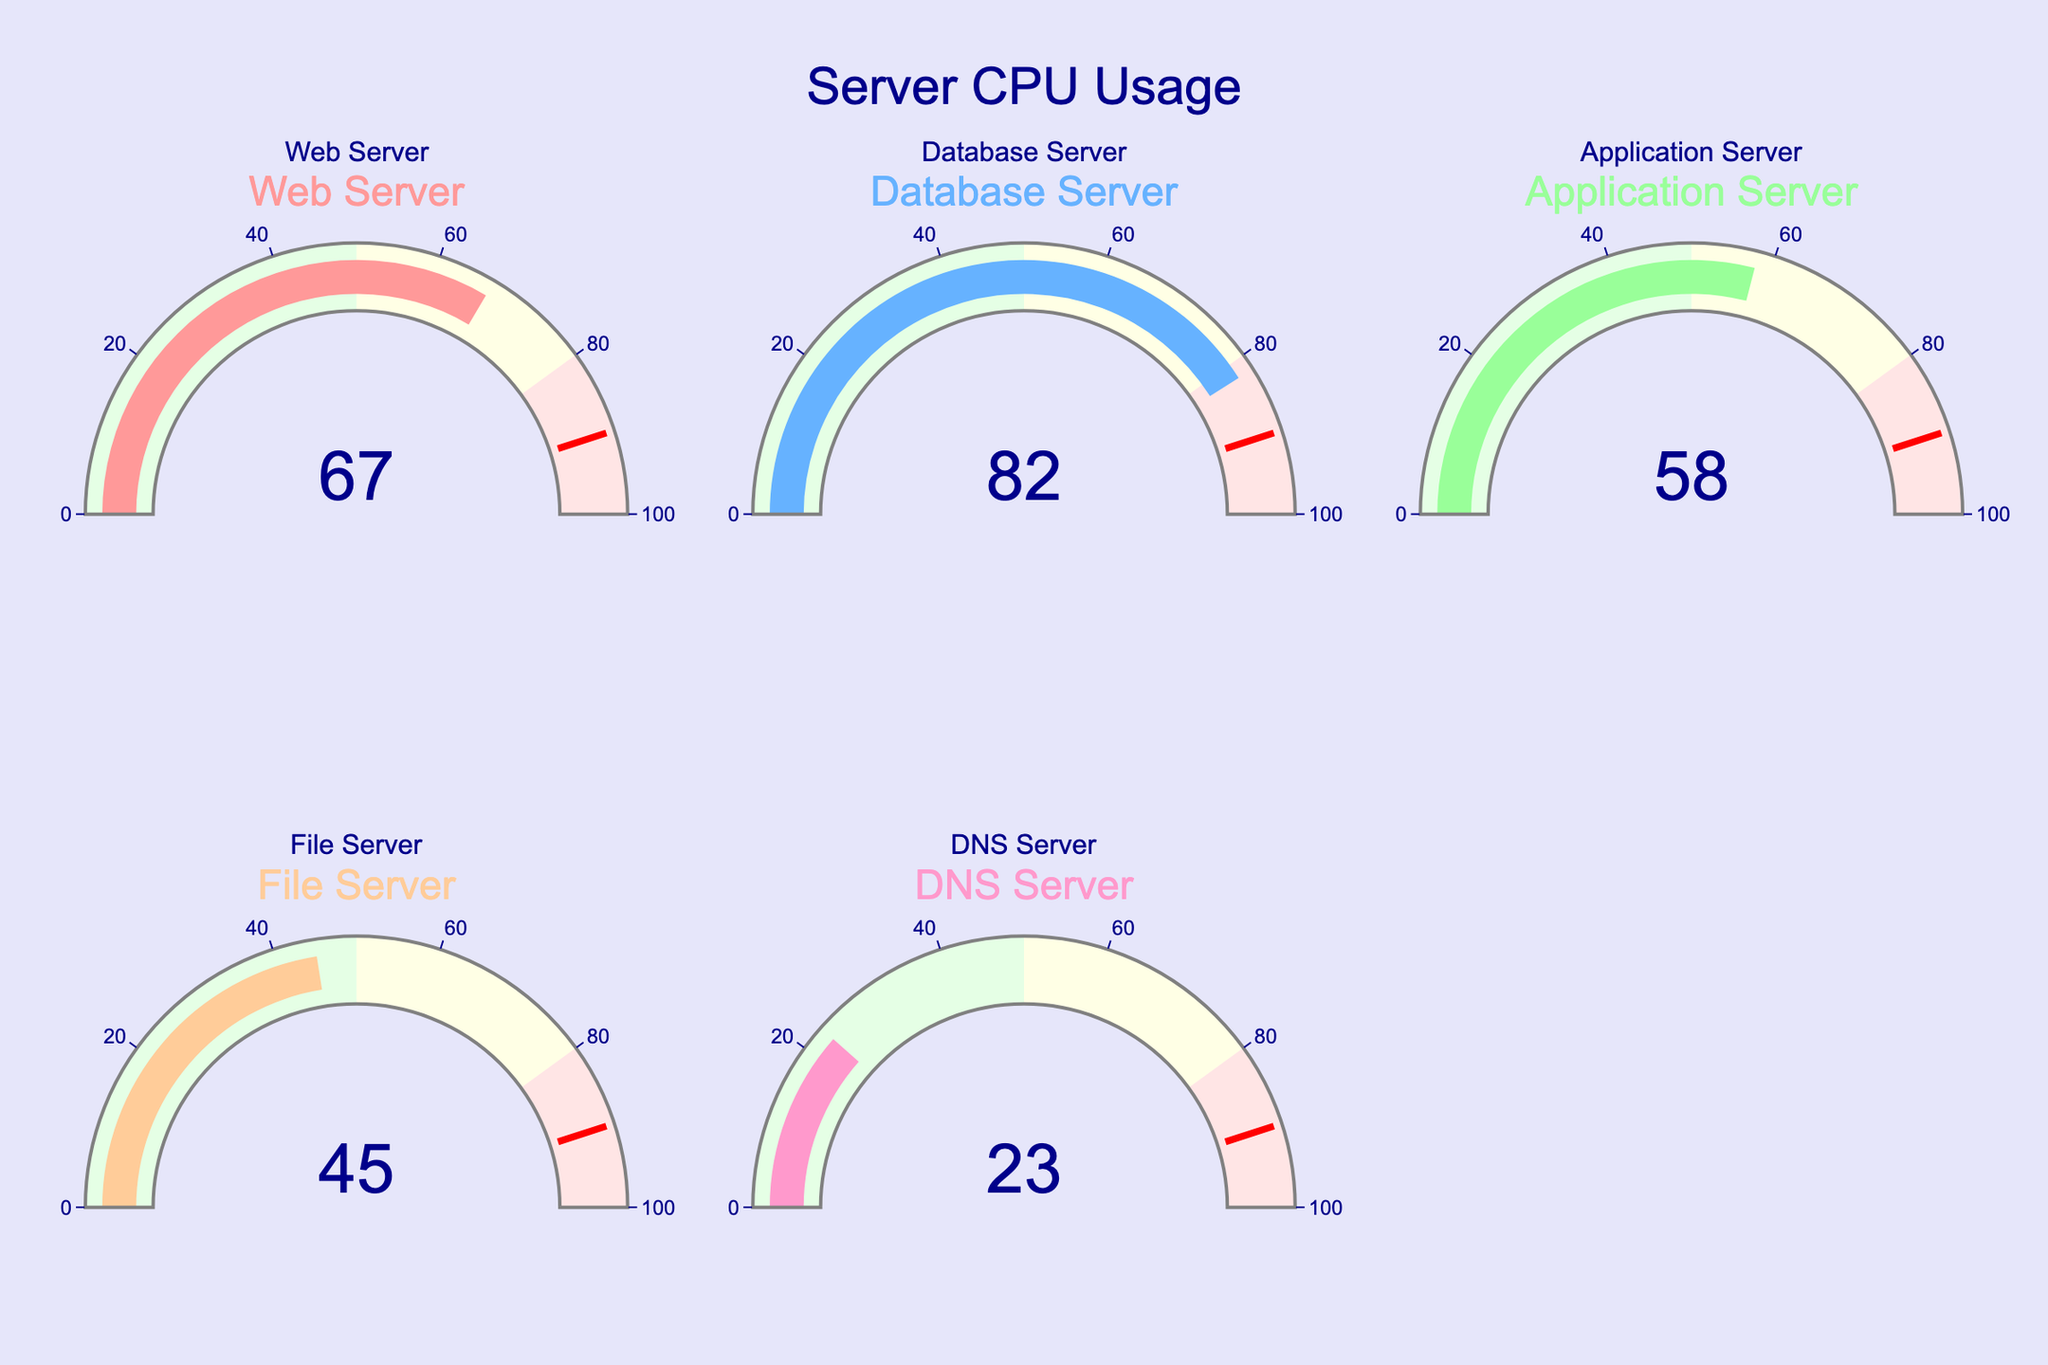What's the CPU usage of the Web Server? The gauge for the Web Server shows a usage of 67, indicated by the central number in the gauge.
Answer: 67 How many servers are represented in the plot? By counting the number of gauges shown, we see there are five servers: Web Server, Database Server, Application Server, File Server, and DNS Server.
Answer: 5 Which server has the highest CPU usage? The Database Server gauge shows the highest CPU usage with a value of 82, which is the largest value among the gauges.
Answer: Database Server What is the difference in CPU usage between the Web Server and the DNS Server? The CPU usage for the Web Server is 67 and for the DNS Server is 23. Subtracting these values gives 67 - 23 = 44.
Answer: 44 Is there any server with CPU usage below 25%? The DNS Server has a CPU usage of 23, which is below 25%.
Answer: Yes What is the average CPU usage across all servers? The CPU usages are 67, 82, 58, 45, and 23. Adding these values gives 67 + 82 + 58 + 45 + 23 = 275. Dividing by the number of servers, 275 / 5 = 55.
Answer: 55 Which server has the lowest CPU usage? The DNS Server has the lowest CPU usage with a value of 23, which is the smallest value among the gauges.
Answer: DNS Server Is the Application Server's CPU usage above 50%? The gauge shows the Application Server with a CPU usage of 58, which is above 50%.
Answer: Yes Which servers have a CPU usage above 60%? The gauges for the Web Server and Database Server show CPU usages of 67 and 82, respectively, both of which are above 60%.
Answer: Web Server, Database Server How much higher is the CPU usage of the Database Server compared to the Application Server? The Database Server's CPU usage is 82 and the Application Server's is 58. Subtracting these values gives 82 - 58 = 24.
Answer: 24 